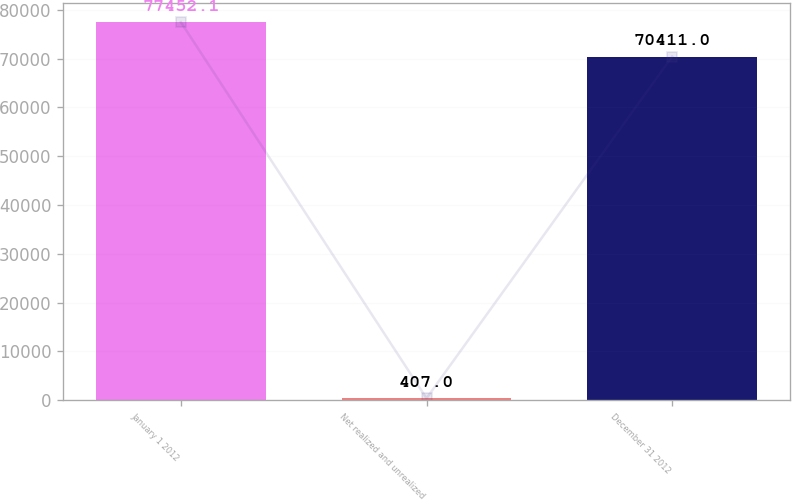<chart> <loc_0><loc_0><loc_500><loc_500><bar_chart><fcel>January 1 2012<fcel>Net realized and unrealized<fcel>December 31 2012<nl><fcel>77452.1<fcel>407<fcel>70411<nl></chart> 